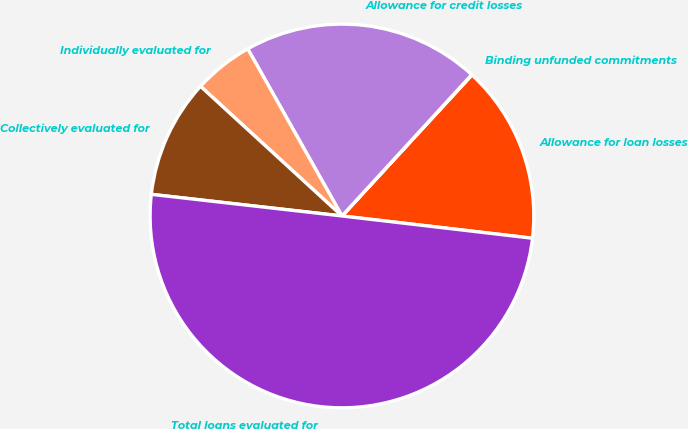Convert chart to OTSL. <chart><loc_0><loc_0><loc_500><loc_500><pie_chart><fcel>Allowance for loan losses<fcel>Binding unfunded commitments<fcel>Allowance for credit losses<fcel>Individually evaluated for<fcel>Collectively evaluated for<fcel>Total loans evaluated for<nl><fcel>15.0%<fcel>0.03%<fcel>19.99%<fcel>5.02%<fcel>10.01%<fcel>49.94%<nl></chart> 